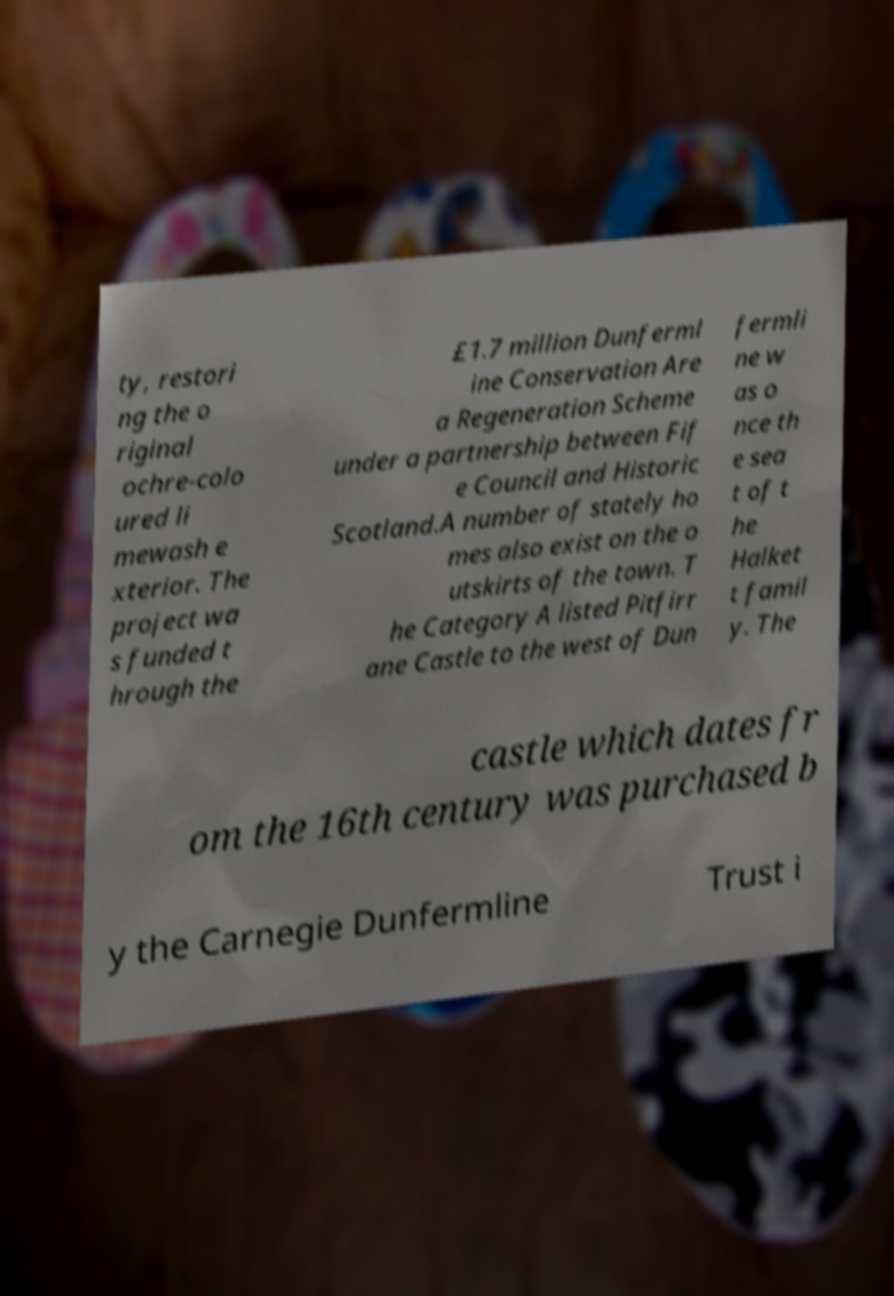Please read and relay the text visible in this image. What does it say? ty, restori ng the o riginal ochre-colo ured li mewash e xterior. The project wa s funded t hrough the £1.7 million Dunferml ine Conservation Are a Regeneration Scheme under a partnership between Fif e Council and Historic Scotland.A number of stately ho mes also exist on the o utskirts of the town. T he Category A listed Pitfirr ane Castle to the west of Dun fermli ne w as o nce th e sea t of t he Halket t famil y. The castle which dates fr om the 16th century was purchased b y the Carnegie Dunfermline Trust i 